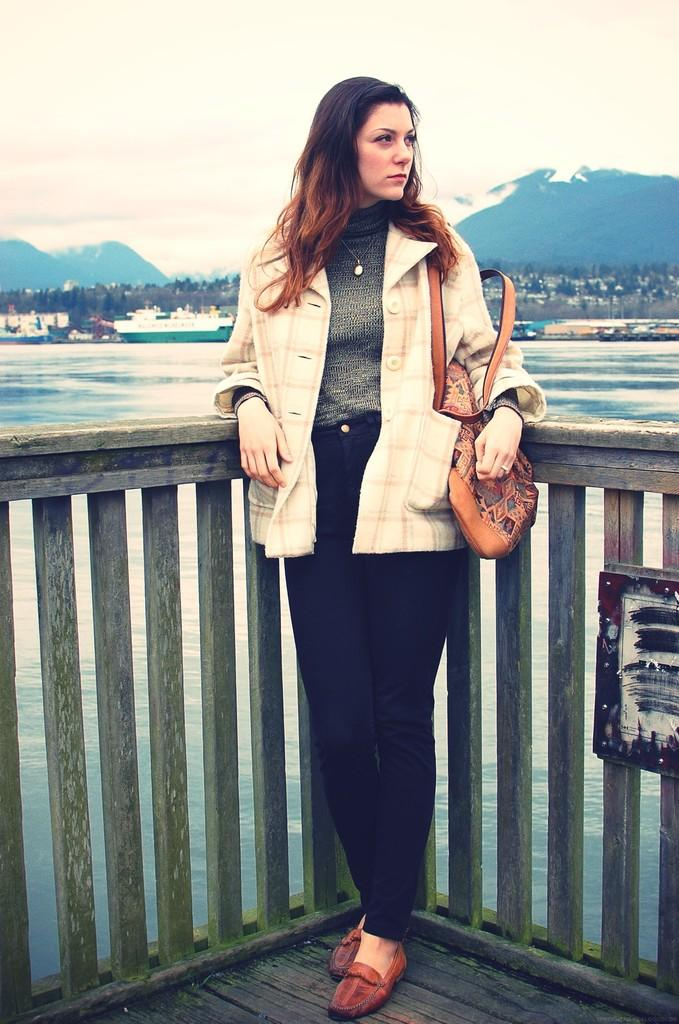Who is present in the image? There is a lady in the image. What is the lady holding in the image? The lady is holding a bag. Where is the lady standing in the image? The lady is standing on a bridge. What can be seen in the water below the bridge? There are ships in the water. What type of vegetation is visible in the image? There are trees in the image. What type of geographical feature is visible in the background? There are mountains in the image. What is visible above the lady and the bridge? The sky is visible in the image. Can you find the receipt for the pickle purchase in the image? There is no receipt or pickle purchase present in the image. 